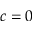Convert formula to latex. <formula><loc_0><loc_0><loc_500><loc_500>c = 0</formula> 